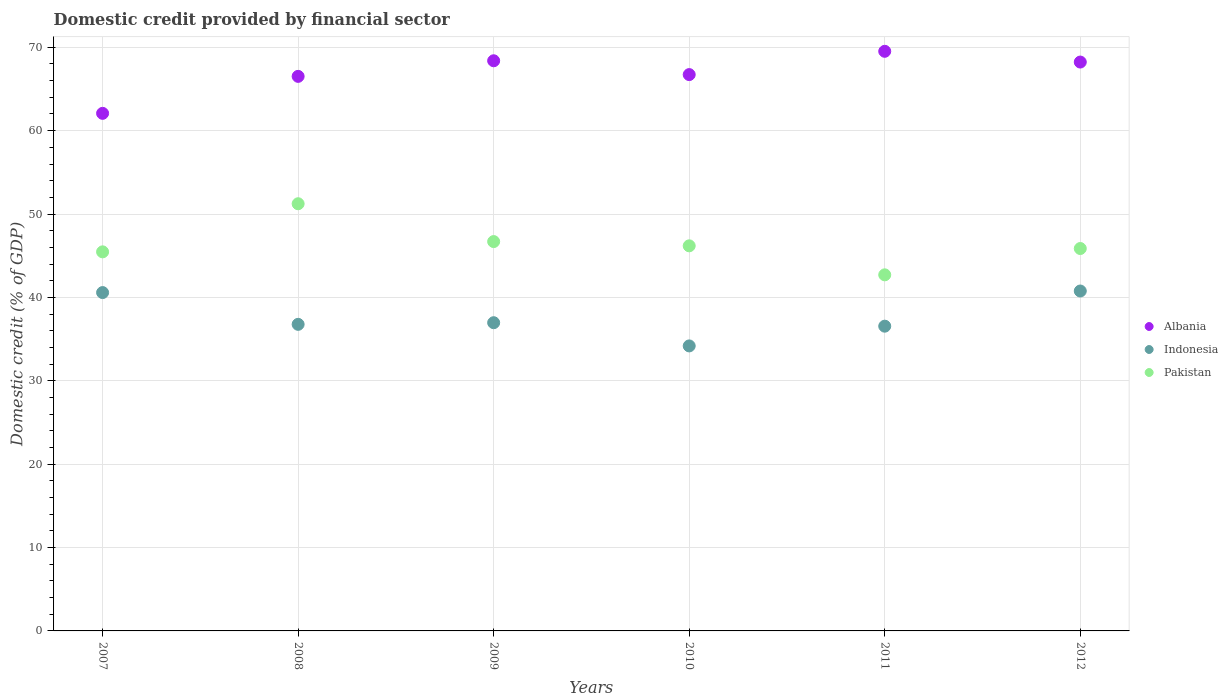How many different coloured dotlines are there?
Offer a very short reply. 3. What is the domestic credit in Albania in 2011?
Keep it short and to the point. 69.52. Across all years, what is the maximum domestic credit in Indonesia?
Ensure brevity in your answer.  40.77. Across all years, what is the minimum domestic credit in Indonesia?
Provide a short and direct response. 34.18. In which year was the domestic credit in Albania maximum?
Offer a very short reply. 2011. In which year was the domestic credit in Albania minimum?
Keep it short and to the point. 2007. What is the total domestic credit in Albania in the graph?
Your answer should be compact. 401.44. What is the difference between the domestic credit in Pakistan in 2007 and that in 2008?
Provide a succinct answer. -5.77. What is the difference between the domestic credit in Indonesia in 2008 and the domestic credit in Albania in 2009?
Your answer should be very brief. -31.61. What is the average domestic credit in Indonesia per year?
Your answer should be compact. 37.64. In the year 2012, what is the difference between the domestic credit in Indonesia and domestic credit in Pakistan?
Your answer should be very brief. -5.1. In how many years, is the domestic credit in Indonesia greater than 66 %?
Give a very brief answer. 0. What is the ratio of the domestic credit in Albania in 2008 to that in 2010?
Provide a short and direct response. 1. Is the difference between the domestic credit in Indonesia in 2009 and 2010 greater than the difference between the domestic credit in Pakistan in 2009 and 2010?
Give a very brief answer. Yes. What is the difference between the highest and the second highest domestic credit in Pakistan?
Make the answer very short. 4.54. What is the difference between the highest and the lowest domestic credit in Indonesia?
Your response must be concise. 6.59. In how many years, is the domestic credit in Pakistan greater than the average domestic credit in Pakistan taken over all years?
Your answer should be compact. 2. Is the domestic credit in Indonesia strictly greater than the domestic credit in Pakistan over the years?
Give a very brief answer. No. How many dotlines are there?
Offer a very short reply. 3. What is the difference between two consecutive major ticks on the Y-axis?
Make the answer very short. 10. Are the values on the major ticks of Y-axis written in scientific E-notation?
Your response must be concise. No. Does the graph contain any zero values?
Offer a terse response. No. Does the graph contain grids?
Your response must be concise. Yes. Where does the legend appear in the graph?
Offer a very short reply. Center right. How many legend labels are there?
Your answer should be compact. 3. What is the title of the graph?
Your answer should be very brief. Domestic credit provided by financial sector. Does "Ecuador" appear as one of the legend labels in the graph?
Give a very brief answer. No. What is the label or title of the X-axis?
Provide a succinct answer. Years. What is the label or title of the Y-axis?
Provide a succinct answer. Domestic credit (% of GDP). What is the Domestic credit (% of GDP) of Albania in 2007?
Your answer should be compact. 62.08. What is the Domestic credit (% of GDP) in Indonesia in 2007?
Ensure brevity in your answer.  40.58. What is the Domestic credit (% of GDP) in Pakistan in 2007?
Ensure brevity in your answer.  45.46. What is the Domestic credit (% of GDP) of Albania in 2008?
Ensure brevity in your answer.  66.51. What is the Domestic credit (% of GDP) of Indonesia in 2008?
Your response must be concise. 36.77. What is the Domestic credit (% of GDP) in Pakistan in 2008?
Give a very brief answer. 51.23. What is the Domestic credit (% of GDP) in Albania in 2009?
Offer a terse response. 68.38. What is the Domestic credit (% of GDP) in Indonesia in 2009?
Provide a succinct answer. 36.97. What is the Domestic credit (% of GDP) in Pakistan in 2009?
Provide a short and direct response. 46.7. What is the Domestic credit (% of GDP) in Albania in 2010?
Ensure brevity in your answer.  66.72. What is the Domestic credit (% of GDP) of Indonesia in 2010?
Your answer should be compact. 34.18. What is the Domestic credit (% of GDP) in Pakistan in 2010?
Give a very brief answer. 46.19. What is the Domestic credit (% of GDP) in Albania in 2011?
Keep it short and to the point. 69.52. What is the Domestic credit (% of GDP) in Indonesia in 2011?
Provide a short and direct response. 36.55. What is the Domestic credit (% of GDP) of Pakistan in 2011?
Provide a short and direct response. 42.71. What is the Domestic credit (% of GDP) in Albania in 2012?
Provide a succinct answer. 68.23. What is the Domestic credit (% of GDP) in Indonesia in 2012?
Your answer should be compact. 40.77. What is the Domestic credit (% of GDP) of Pakistan in 2012?
Keep it short and to the point. 45.86. Across all years, what is the maximum Domestic credit (% of GDP) in Albania?
Offer a terse response. 69.52. Across all years, what is the maximum Domestic credit (% of GDP) of Indonesia?
Give a very brief answer. 40.77. Across all years, what is the maximum Domestic credit (% of GDP) of Pakistan?
Keep it short and to the point. 51.23. Across all years, what is the minimum Domestic credit (% of GDP) in Albania?
Your answer should be very brief. 62.08. Across all years, what is the minimum Domestic credit (% of GDP) in Indonesia?
Provide a short and direct response. 34.18. Across all years, what is the minimum Domestic credit (% of GDP) in Pakistan?
Provide a succinct answer. 42.71. What is the total Domestic credit (% of GDP) of Albania in the graph?
Offer a terse response. 401.44. What is the total Domestic credit (% of GDP) in Indonesia in the graph?
Offer a very short reply. 225.82. What is the total Domestic credit (% of GDP) of Pakistan in the graph?
Make the answer very short. 278.15. What is the difference between the Domestic credit (% of GDP) in Albania in 2007 and that in 2008?
Offer a terse response. -4.44. What is the difference between the Domestic credit (% of GDP) of Indonesia in 2007 and that in 2008?
Your answer should be very brief. 3.81. What is the difference between the Domestic credit (% of GDP) in Pakistan in 2007 and that in 2008?
Provide a short and direct response. -5.77. What is the difference between the Domestic credit (% of GDP) of Albania in 2007 and that in 2009?
Your response must be concise. -6.31. What is the difference between the Domestic credit (% of GDP) in Indonesia in 2007 and that in 2009?
Your response must be concise. 3.61. What is the difference between the Domestic credit (% of GDP) in Pakistan in 2007 and that in 2009?
Keep it short and to the point. -1.23. What is the difference between the Domestic credit (% of GDP) in Albania in 2007 and that in 2010?
Your answer should be very brief. -4.65. What is the difference between the Domestic credit (% of GDP) of Indonesia in 2007 and that in 2010?
Offer a very short reply. 6.4. What is the difference between the Domestic credit (% of GDP) of Pakistan in 2007 and that in 2010?
Your answer should be compact. -0.72. What is the difference between the Domestic credit (% of GDP) of Albania in 2007 and that in 2011?
Your answer should be compact. -7.44. What is the difference between the Domestic credit (% of GDP) of Indonesia in 2007 and that in 2011?
Give a very brief answer. 4.03. What is the difference between the Domestic credit (% of GDP) in Pakistan in 2007 and that in 2011?
Provide a succinct answer. 2.76. What is the difference between the Domestic credit (% of GDP) of Albania in 2007 and that in 2012?
Offer a terse response. -6.15. What is the difference between the Domestic credit (% of GDP) in Indonesia in 2007 and that in 2012?
Make the answer very short. -0.19. What is the difference between the Domestic credit (% of GDP) of Pakistan in 2007 and that in 2012?
Your response must be concise. -0.4. What is the difference between the Domestic credit (% of GDP) of Albania in 2008 and that in 2009?
Your response must be concise. -1.87. What is the difference between the Domestic credit (% of GDP) of Indonesia in 2008 and that in 2009?
Offer a terse response. -0.2. What is the difference between the Domestic credit (% of GDP) of Pakistan in 2008 and that in 2009?
Offer a very short reply. 4.54. What is the difference between the Domestic credit (% of GDP) of Albania in 2008 and that in 2010?
Ensure brevity in your answer.  -0.21. What is the difference between the Domestic credit (% of GDP) in Indonesia in 2008 and that in 2010?
Your answer should be very brief. 2.59. What is the difference between the Domestic credit (% of GDP) in Pakistan in 2008 and that in 2010?
Keep it short and to the point. 5.05. What is the difference between the Domestic credit (% of GDP) in Albania in 2008 and that in 2011?
Offer a very short reply. -3.01. What is the difference between the Domestic credit (% of GDP) in Indonesia in 2008 and that in 2011?
Provide a succinct answer. 0.22. What is the difference between the Domestic credit (% of GDP) in Pakistan in 2008 and that in 2011?
Your answer should be compact. 8.53. What is the difference between the Domestic credit (% of GDP) of Albania in 2008 and that in 2012?
Provide a succinct answer. -1.72. What is the difference between the Domestic credit (% of GDP) of Indonesia in 2008 and that in 2012?
Your response must be concise. -4. What is the difference between the Domestic credit (% of GDP) of Pakistan in 2008 and that in 2012?
Ensure brevity in your answer.  5.37. What is the difference between the Domestic credit (% of GDP) of Albania in 2009 and that in 2010?
Give a very brief answer. 1.66. What is the difference between the Domestic credit (% of GDP) of Indonesia in 2009 and that in 2010?
Provide a short and direct response. 2.78. What is the difference between the Domestic credit (% of GDP) in Pakistan in 2009 and that in 2010?
Offer a very short reply. 0.51. What is the difference between the Domestic credit (% of GDP) in Albania in 2009 and that in 2011?
Your answer should be compact. -1.14. What is the difference between the Domestic credit (% of GDP) in Indonesia in 2009 and that in 2011?
Provide a short and direct response. 0.42. What is the difference between the Domestic credit (% of GDP) of Pakistan in 2009 and that in 2011?
Provide a succinct answer. 3.99. What is the difference between the Domestic credit (% of GDP) of Albania in 2009 and that in 2012?
Provide a short and direct response. 0.15. What is the difference between the Domestic credit (% of GDP) in Indonesia in 2009 and that in 2012?
Offer a terse response. -3.8. What is the difference between the Domestic credit (% of GDP) in Pakistan in 2009 and that in 2012?
Provide a short and direct response. 0.83. What is the difference between the Domestic credit (% of GDP) of Albania in 2010 and that in 2011?
Make the answer very short. -2.79. What is the difference between the Domestic credit (% of GDP) of Indonesia in 2010 and that in 2011?
Your answer should be very brief. -2.37. What is the difference between the Domestic credit (% of GDP) in Pakistan in 2010 and that in 2011?
Provide a short and direct response. 3.48. What is the difference between the Domestic credit (% of GDP) in Albania in 2010 and that in 2012?
Ensure brevity in your answer.  -1.5. What is the difference between the Domestic credit (% of GDP) of Indonesia in 2010 and that in 2012?
Keep it short and to the point. -6.59. What is the difference between the Domestic credit (% of GDP) of Pakistan in 2010 and that in 2012?
Offer a very short reply. 0.32. What is the difference between the Domestic credit (% of GDP) in Albania in 2011 and that in 2012?
Make the answer very short. 1.29. What is the difference between the Domestic credit (% of GDP) of Indonesia in 2011 and that in 2012?
Keep it short and to the point. -4.22. What is the difference between the Domestic credit (% of GDP) of Pakistan in 2011 and that in 2012?
Offer a terse response. -3.16. What is the difference between the Domestic credit (% of GDP) of Albania in 2007 and the Domestic credit (% of GDP) of Indonesia in 2008?
Give a very brief answer. 25.31. What is the difference between the Domestic credit (% of GDP) in Albania in 2007 and the Domestic credit (% of GDP) in Pakistan in 2008?
Your response must be concise. 10.84. What is the difference between the Domestic credit (% of GDP) of Indonesia in 2007 and the Domestic credit (% of GDP) of Pakistan in 2008?
Ensure brevity in your answer.  -10.65. What is the difference between the Domestic credit (% of GDP) of Albania in 2007 and the Domestic credit (% of GDP) of Indonesia in 2009?
Your response must be concise. 25.11. What is the difference between the Domestic credit (% of GDP) of Albania in 2007 and the Domestic credit (% of GDP) of Pakistan in 2009?
Your response must be concise. 15.38. What is the difference between the Domestic credit (% of GDP) in Indonesia in 2007 and the Domestic credit (% of GDP) in Pakistan in 2009?
Your answer should be compact. -6.12. What is the difference between the Domestic credit (% of GDP) in Albania in 2007 and the Domestic credit (% of GDP) in Indonesia in 2010?
Ensure brevity in your answer.  27.89. What is the difference between the Domestic credit (% of GDP) of Albania in 2007 and the Domestic credit (% of GDP) of Pakistan in 2010?
Give a very brief answer. 15.89. What is the difference between the Domestic credit (% of GDP) in Indonesia in 2007 and the Domestic credit (% of GDP) in Pakistan in 2010?
Ensure brevity in your answer.  -5.61. What is the difference between the Domestic credit (% of GDP) of Albania in 2007 and the Domestic credit (% of GDP) of Indonesia in 2011?
Ensure brevity in your answer.  25.53. What is the difference between the Domestic credit (% of GDP) in Albania in 2007 and the Domestic credit (% of GDP) in Pakistan in 2011?
Your response must be concise. 19.37. What is the difference between the Domestic credit (% of GDP) in Indonesia in 2007 and the Domestic credit (% of GDP) in Pakistan in 2011?
Ensure brevity in your answer.  -2.13. What is the difference between the Domestic credit (% of GDP) in Albania in 2007 and the Domestic credit (% of GDP) in Indonesia in 2012?
Keep it short and to the point. 21.31. What is the difference between the Domestic credit (% of GDP) of Albania in 2007 and the Domestic credit (% of GDP) of Pakistan in 2012?
Offer a very short reply. 16.21. What is the difference between the Domestic credit (% of GDP) of Indonesia in 2007 and the Domestic credit (% of GDP) of Pakistan in 2012?
Keep it short and to the point. -5.28. What is the difference between the Domestic credit (% of GDP) of Albania in 2008 and the Domestic credit (% of GDP) of Indonesia in 2009?
Provide a succinct answer. 29.55. What is the difference between the Domestic credit (% of GDP) of Albania in 2008 and the Domestic credit (% of GDP) of Pakistan in 2009?
Provide a short and direct response. 19.82. What is the difference between the Domestic credit (% of GDP) of Indonesia in 2008 and the Domestic credit (% of GDP) of Pakistan in 2009?
Ensure brevity in your answer.  -9.93. What is the difference between the Domestic credit (% of GDP) of Albania in 2008 and the Domestic credit (% of GDP) of Indonesia in 2010?
Your answer should be very brief. 32.33. What is the difference between the Domestic credit (% of GDP) of Albania in 2008 and the Domestic credit (% of GDP) of Pakistan in 2010?
Your answer should be very brief. 20.33. What is the difference between the Domestic credit (% of GDP) in Indonesia in 2008 and the Domestic credit (% of GDP) in Pakistan in 2010?
Offer a terse response. -9.42. What is the difference between the Domestic credit (% of GDP) in Albania in 2008 and the Domestic credit (% of GDP) in Indonesia in 2011?
Keep it short and to the point. 29.96. What is the difference between the Domestic credit (% of GDP) in Albania in 2008 and the Domestic credit (% of GDP) in Pakistan in 2011?
Keep it short and to the point. 23.8. What is the difference between the Domestic credit (% of GDP) in Indonesia in 2008 and the Domestic credit (% of GDP) in Pakistan in 2011?
Your answer should be very brief. -5.94. What is the difference between the Domestic credit (% of GDP) in Albania in 2008 and the Domestic credit (% of GDP) in Indonesia in 2012?
Your answer should be compact. 25.74. What is the difference between the Domestic credit (% of GDP) in Albania in 2008 and the Domestic credit (% of GDP) in Pakistan in 2012?
Make the answer very short. 20.65. What is the difference between the Domestic credit (% of GDP) of Indonesia in 2008 and the Domestic credit (% of GDP) of Pakistan in 2012?
Offer a terse response. -9.09. What is the difference between the Domestic credit (% of GDP) of Albania in 2009 and the Domestic credit (% of GDP) of Indonesia in 2010?
Your answer should be very brief. 34.2. What is the difference between the Domestic credit (% of GDP) of Albania in 2009 and the Domestic credit (% of GDP) of Pakistan in 2010?
Give a very brief answer. 22.2. What is the difference between the Domestic credit (% of GDP) of Indonesia in 2009 and the Domestic credit (% of GDP) of Pakistan in 2010?
Give a very brief answer. -9.22. What is the difference between the Domestic credit (% of GDP) of Albania in 2009 and the Domestic credit (% of GDP) of Indonesia in 2011?
Offer a very short reply. 31.83. What is the difference between the Domestic credit (% of GDP) of Albania in 2009 and the Domestic credit (% of GDP) of Pakistan in 2011?
Offer a terse response. 25.67. What is the difference between the Domestic credit (% of GDP) of Indonesia in 2009 and the Domestic credit (% of GDP) of Pakistan in 2011?
Keep it short and to the point. -5.74. What is the difference between the Domestic credit (% of GDP) in Albania in 2009 and the Domestic credit (% of GDP) in Indonesia in 2012?
Your response must be concise. 27.61. What is the difference between the Domestic credit (% of GDP) in Albania in 2009 and the Domestic credit (% of GDP) in Pakistan in 2012?
Your answer should be very brief. 22.52. What is the difference between the Domestic credit (% of GDP) in Indonesia in 2009 and the Domestic credit (% of GDP) in Pakistan in 2012?
Offer a terse response. -8.9. What is the difference between the Domestic credit (% of GDP) of Albania in 2010 and the Domestic credit (% of GDP) of Indonesia in 2011?
Make the answer very short. 30.17. What is the difference between the Domestic credit (% of GDP) in Albania in 2010 and the Domestic credit (% of GDP) in Pakistan in 2011?
Ensure brevity in your answer.  24.02. What is the difference between the Domestic credit (% of GDP) in Indonesia in 2010 and the Domestic credit (% of GDP) in Pakistan in 2011?
Keep it short and to the point. -8.53. What is the difference between the Domestic credit (% of GDP) in Albania in 2010 and the Domestic credit (% of GDP) in Indonesia in 2012?
Make the answer very short. 25.96. What is the difference between the Domestic credit (% of GDP) of Albania in 2010 and the Domestic credit (% of GDP) of Pakistan in 2012?
Provide a short and direct response. 20.86. What is the difference between the Domestic credit (% of GDP) of Indonesia in 2010 and the Domestic credit (% of GDP) of Pakistan in 2012?
Make the answer very short. -11.68. What is the difference between the Domestic credit (% of GDP) in Albania in 2011 and the Domestic credit (% of GDP) in Indonesia in 2012?
Make the answer very short. 28.75. What is the difference between the Domestic credit (% of GDP) in Albania in 2011 and the Domestic credit (% of GDP) in Pakistan in 2012?
Your response must be concise. 23.65. What is the difference between the Domestic credit (% of GDP) in Indonesia in 2011 and the Domestic credit (% of GDP) in Pakistan in 2012?
Make the answer very short. -9.31. What is the average Domestic credit (% of GDP) of Albania per year?
Give a very brief answer. 66.91. What is the average Domestic credit (% of GDP) in Indonesia per year?
Your response must be concise. 37.64. What is the average Domestic credit (% of GDP) in Pakistan per year?
Offer a very short reply. 46.36. In the year 2007, what is the difference between the Domestic credit (% of GDP) of Albania and Domestic credit (% of GDP) of Indonesia?
Make the answer very short. 21.5. In the year 2007, what is the difference between the Domestic credit (% of GDP) in Albania and Domestic credit (% of GDP) in Pakistan?
Make the answer very short. 16.61. In the year 2007, what is the difference between the Domestic credit (% of GDP) in Indonesia and Domestic credit (% of GDP) in Pakistan?
Your response must be concise. -4.88. In the year 2008, what is the difference between the Domestic credit (% of GDP) in Albania and Domestic credit (% of GDP) in Indonesia?
Your response must be concise. 29.74. In the year 2008, what is the difference between the Domestic credit (% of GDP) of Albania and Domestic credit (% of GDP) of Pakistan?
Make the answer very short. 15.28. In the year 2008, what is the difference between the Domestic credit (% of GDP) of Indonesia and Domestic credit (% of GDP) of Pakistan?
Your response must be concise. -14.46. In the year 2009, what is the difference between the Domestic credit (% of GDP) in Albania and Domestic credit (% of GDP) in Indonesia?
Offer a terse response. 31.42. In the year 2009, what is the difference between the Domestic credit (% of GDP) in Albania and Domestic credit (% of GDP) in Pakistan?
Make the answer very short. 21.69. In the year 2009, what is the difference between the Domestic credit (% of GDP) of Indonesia and Domestic credit (% of GDP) of Pakistan?
Give a very brief answer. -9.73. In the year 2010, what is the difference between the Domestic credit (% of GDP) of Albania and Domestic credit (% of GDP) of Indonesia?
Offer a terse response. 32.54. In the year 2010, what is the difference between the Domestic credit (% of GDP) of Albania and Domestic credit (% of GDP) of Pakistan?
Your response must be concise. 20.54. In the year 2010, what is the difference between the Domestic credit (% of GDP) of Indonesia and Domestic credit (% of GDP) of Pakistan?
Your answer should be compact. -12. In the year 2011, what is the difference between the Domestic credit (% of GDP) in Albania and Domestic credit (% of GDP) in Indonesia?
Give a very brief answer. 32.97. In the year 2011, what is the difference between the Domestic credit (% of GDP) of Albania and Domestic credit (% of GDP) of Pakistan?
Offer a very short reply. 26.81. In the year 2011, what is the difference between the Domestic credit (% of GDP) of Indonesia and Domestic credit (% of GDP) of Pakistan?
Keep it short and to the point. -6.16. In the year 2012, what is the difference between the Domestic credit (% of GDP) of Albania and Domestic credit (% of GDP) of Indonesia?
Your answer should be very brief. 27.46. In the year 2012, what is the difference between the Domestic credit (% of GDP) of Albania and Domestic credit (% of GDP) of Pakistan?
Ensure brevity in your answer.  22.36. In the year 2012, what is the difference between the Domestic credit (% of GDP) in Indonesia and Domestic credit (% of GDP) in Pakistan?
Offer a very short reply. -5.1. What is the ratio of the Domestic credit (% of GDP) of Albania in 2007 to that in 2008?
Give a very brief answer. 0.93. What is the ratio of the Domestic credit (% of GDP) of Indonesia in 2007 to that in 2008?
Provide a succinct answer. 1.1. What is the ratio of the Domestic credit (% of GDP) of Pakistan in 2007 to that in 2008?
Make the answer very short. 0.89. What is the ratio of the Domestic credit (% of GDP) of Albania in 2007 to that in 2009?
Provide a succinct answer. 0.91. What is the ratio of the Domestic credit (% of GDP) of Indonesia in 2007 to that in 2009?
Make the answer very short. 1.1. What is the ratio of the Domestic credit (% of GDP) of Pakistan in 2007 to that in 2009?
Keep it short and to the point. 0.97. What is the ratio of the Domestic credit (% of GDP) of Albania in 2007 to that in 2010?
Your response must be concise. 0.93. What is the ratio of the Domestic credit (% of GDP) of Indonesia in 2007 to that in 2010?
Provide a succinct answer. 1.19. What is the ratio of the Domestic credit (% of GDP) in Pakistan in 2007 to that in 2010?
Your answer should be compact. 0.98. What is the ratio of the Domestic credit (% of GDP) of Albania in 2007 to that in 2011?
Keep it short and to the point. 0.89. What is the ratio of the Domestic credit (% of GDP) in Indonesia in 2007 to that in 2011?
Make the answer very short. 1.11. What is the ratio of the Domestic credit (% of GDP) of Pakistan in 2007 to that in 2011?
Provide a succinct answer. 1.06. What is the ratio of the Domestic credit (% of GDP) of Albania in 2007 to that in 2012?
Give a very brief answer. 0.91. What is the ratio of the Domestic credit (% of GDP) in Indonesia in 2007 to that in 2012?
Your answer should be very brief. 1. What is the ratio of the Domestic credit (% of GDP) in Pakistan in 2007 to that in 2012?
Offer a very short reply. 0.99. What is the ratio of the Domestic credit (% of GDP) in Albania in 2008 to that in 2009?
Make the answer very short. 0.97. What is the ratio of the Domestic credit (% of GDP) in Indonesia in 2008 to that in 2009?
Provide a succinct answer. 0.99. What is the ratio of the Domestic credit (% of GDP) of Pakistan in 2008 to that in 2009?
Offer a very short reply. 1.1. What is the ratio of the Domestic credit (% of GDP) of Indonesia in 2008 to that in 2010?
Ensure brevity in your answer.  1.08. What is the ratio of the Domestic credit (% of GDP) in Pakistan in 2008 to that in 2010?
Make the answer very short. 1.11. What is the ratio of the Domestic credit (% of GDP) in Albania in 2008 to that in 2011?
Your answer should be very brief. 0.96. What is the ratio of the Domestic credit (% of GDP) in Indonesia in 2008 to that in 2011?
Offer a terse response. 1.01. What is the ratio of the Domestic credit (% of GDP) in Pakistan in 2008 to that in 2011?
Your answer should be very brief. 1.2. What is the ratio of the Domestic credit (% of GDP) in Albania in 2008 to that in 2012?
Make the answer very short. 0.97. What is the ratio of the Domestic credit (% of GDP) of Indonesia in 2008 to that in 2012?
Keep it short and to the point. 0.9. What is the ratio of the Domestic credit (% of GDP) in Pakistan in 2008 to that in 2012?
Your response must be concise. 1.12. What is the ratio of the Domestic credit (% of GDP) of Albania in 2009 to that in 2010?
Give a very brief answer. 1.02. What is the ratio of the Domestic credit (% of GDP) of Indonesia in 2009 to that in 2010?
Make the answer very short. 1.08. What is the ratio of the Domestic credit (% of GDP) in Pakistan in 2009 to that in 2010?
Give a very brief answer. 1.01. What is the ratio of the Domestic credit (% of GDP) in Albania in 2009 to that in 2011?
Give a very brief answer. 0.98. What is the ratio of the Domestic credit (% of GDP) in Indonesia in 2009 to that in 2011?
Your answer should be very brief. 1.01. What is the ratio of the Domestic credit (% of GDP) in Pakistan in 2009 to that in 2011?
Provide a short and direct response. 1.09. What is the ratio of the Domestic credit (% of GDP) of Albania in 2009 to that in 2012?
Your response must be concise. 1. What is the ratio of the Domestic credit (% of GDP) in Indonesia in 2009 to that in 2012?
Provide a short and direct response. 0.91. What is the ratio of the Domestic credit (% of GDP) of Pakistan in 2009 to that in 2012?
Offer a terse response. 1.02. What is the ratio of the Domestic credit (% of GDP) in Albania in 2010 to that in 2011?
Your answer should be compact. 0.96. What is the ratio of the Domestic credit (% of GDP) of Indonesia in 2010 to that in 2011?
Give a very brief answer. 0.94. What is the ratio of the Domestic credit (% of GDP) in Pakistan in 2010 to that in 2011?
Offer a terse response. 1.08. What is the ratio of the Domestic credit (% of GDP) in Albania in 2010 to that in 2012?
Your answer should be compact. 0.98. What is the ratio of the Domestic credit (% of GDP) of Indonesia in 2010 to that in 2012?
Make the answer very short. 0.84. What is the ratio of the Domestic credit (% of GDP) in Albania in 2011 to that in 2012?
Keep it short and to the point. 1.02. What is the ratio of the Domestic credit (% of GDP) in Indonesia in 2011 to that in 2012?
Ensure brevity in your answer.  0.9. What is the ratio of the Domestic credit (% of GDP) in Pakistan in 2011 to that in 2012?
Ensure brevity in your answer.  0.93. What is the difference between the highest and the second highest Domestic credit (% of GDP) of Albania?
Provide a short and direct response. 1.14. What is the difference between the highest and the second highest Domestic credit (% of GDP) in Indonesia?
Provide a short and direct response. 0.19. What is the difference between the highest and the second highest Domestic credit (% of GDP) in Pakistan?
Offer a terse response. 4.54. What is the difference between the highest and the lowest Domestic credit (% of GDP) in Albania?
Offer a terse response. 7.44. What is the difference between the highest and the lowest Domestic credit (% of GDP) in Indonesia?
Your answer should be very brief. 6.59. What is the difference between the highest and the lowest Domestic credit (% of GDP) of Pakistan?
Offer a terse response. 8.53. 